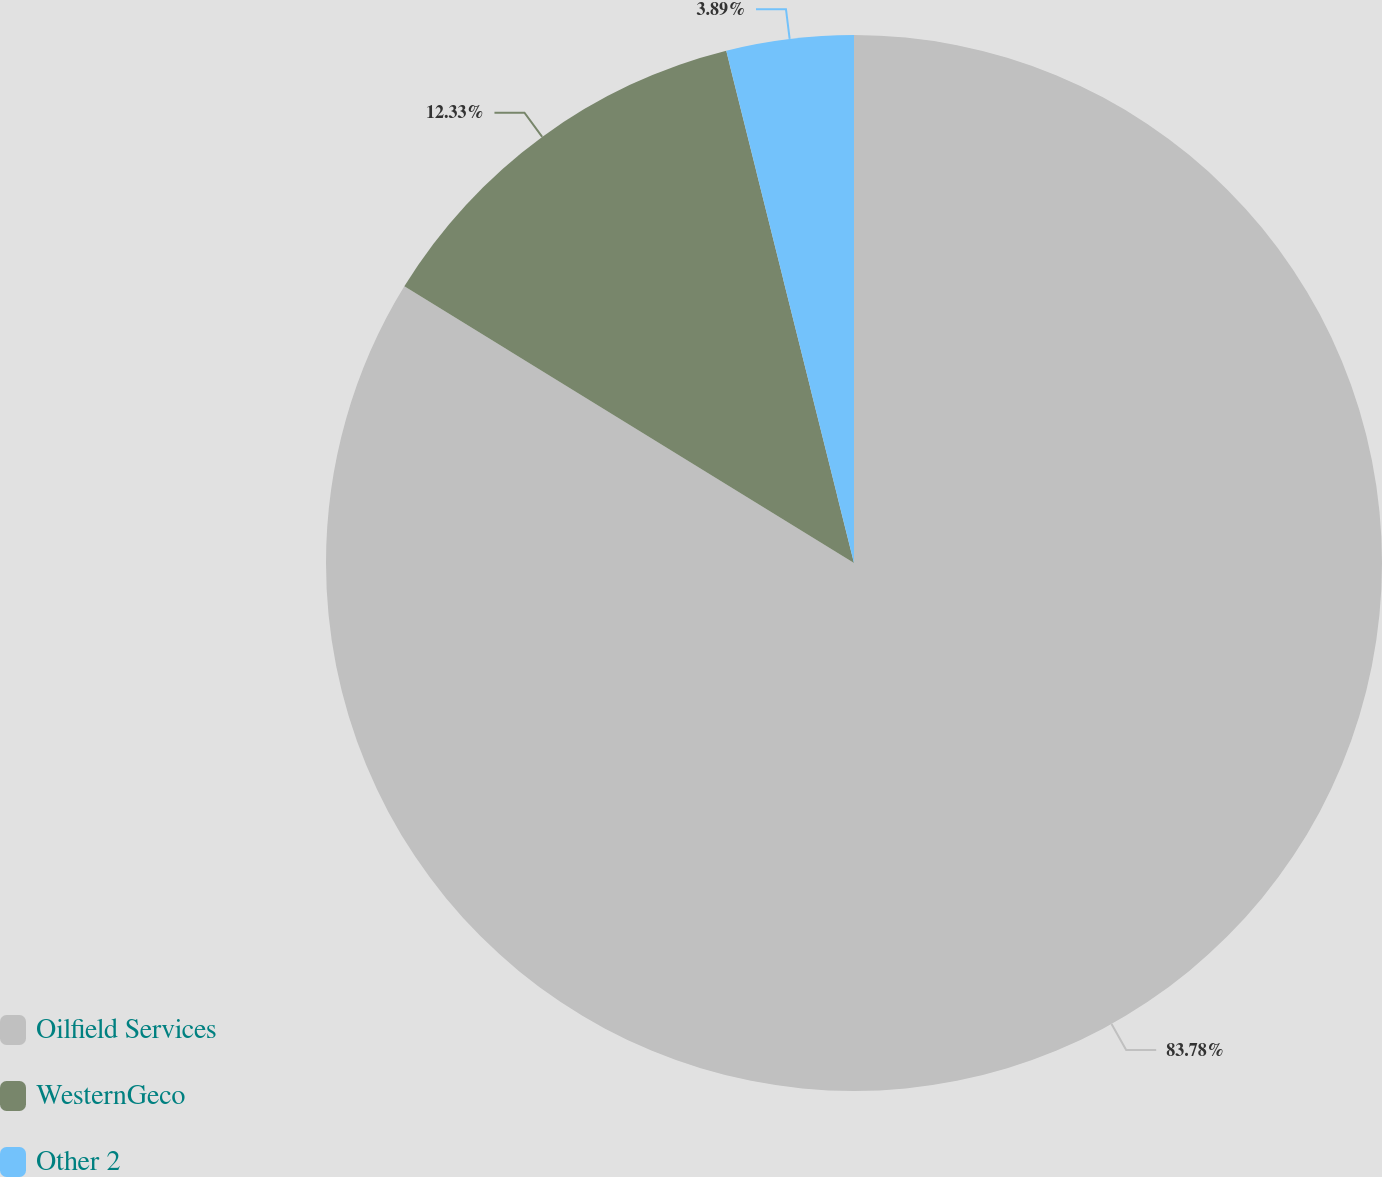Convert chart. <chart><loc_0><loc_0><loc_500><loc_500><pie_chart><fcel>Oilfield Services<fcel>WesternGeco<fcel>Other 2<nl><fcel>83.78%<fcel>12.33%<fcel>3.89%<nl></chart> 